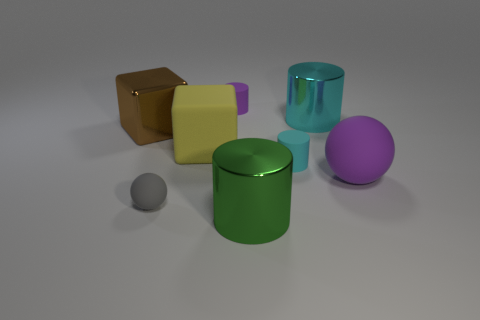How many other objects have the same shape as the big yellow object?
Keep it short and to the point. 1. Are there fewer big purple rubber objects on the left side of the yellow object than spheres that are behind the gray matte thing?
Keep it short and to the point. Yes. What number of big brown objects are on the left side of the metal cylinder in front of the tiny gray rubber thing?
Your answer should be compact. 1. Are there any small purple matte blocks?
Make the answer very short. No. Is there a tiny cylinder that has the same material as the large yellow thing?
Offer a terse response. Yes. Are there more large matte things behind the yellow thing than small cylinders that are in front of the cyan matte cylinder?
Keep it short and to the point. No. Is the size of the purple matte cylinder the same as the cyan shiny thing?
Your answer should be very brief. No. There is a big cylinder that is behind the metallic cylinder that is left of the big cyan thing; what color is it?
Offer a very short reply. Cyan. The small ball has what color?
Offer a terse response. Gray. Is there a matte thing of the same color as the large matte ball?
Offer a very short reply. Yes. 